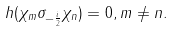<formula> <loc_0><loc_0><loc_500><loc_500>h ( \chi _ { m } \sigma _ { - \frac { i } { 2 } } \chi _ { n } ) = 0 , m \neq n .</formula> 